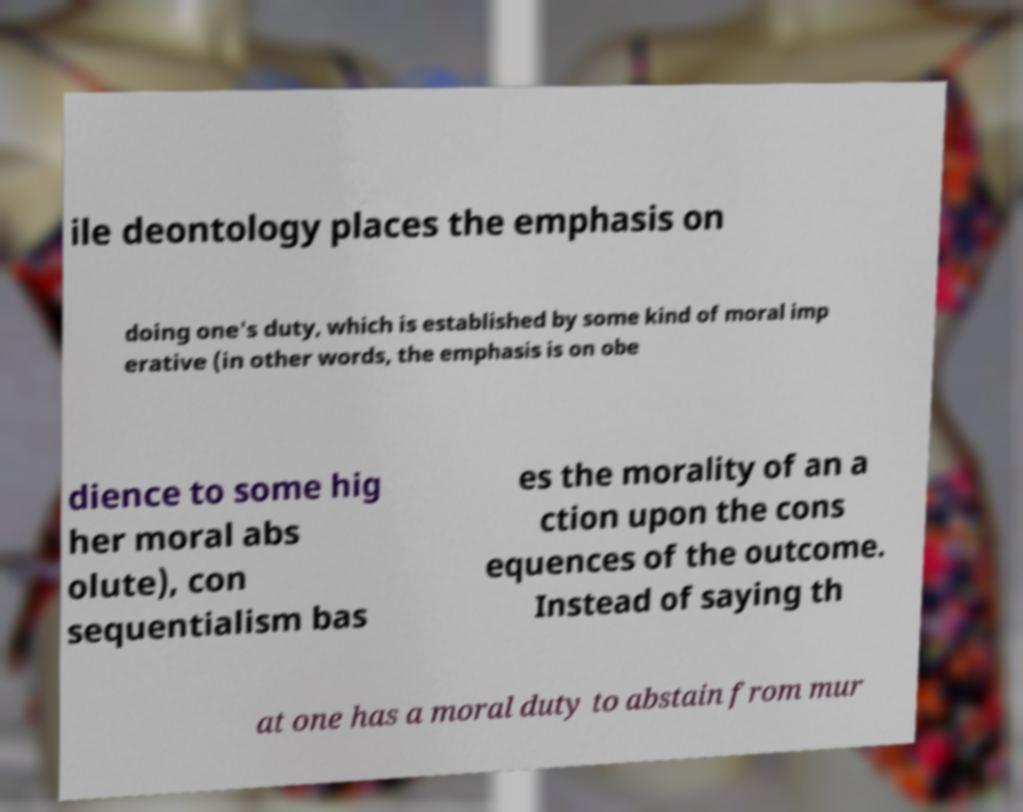Can you read and provide the text displayed in the image?This photo seems to have some interesting text. Can you extract and type it out for me? ile deontology places the emphasis on doing one's duty, which is established by some kind of moral imp erative (in other words, the emphasis is on obe dience to some hig her moral abs olute), con sequentialism bas es the morality of an a ction upon the cons equences of the outcome. Instead of saying th at one has a moral duty to abstain from mur 